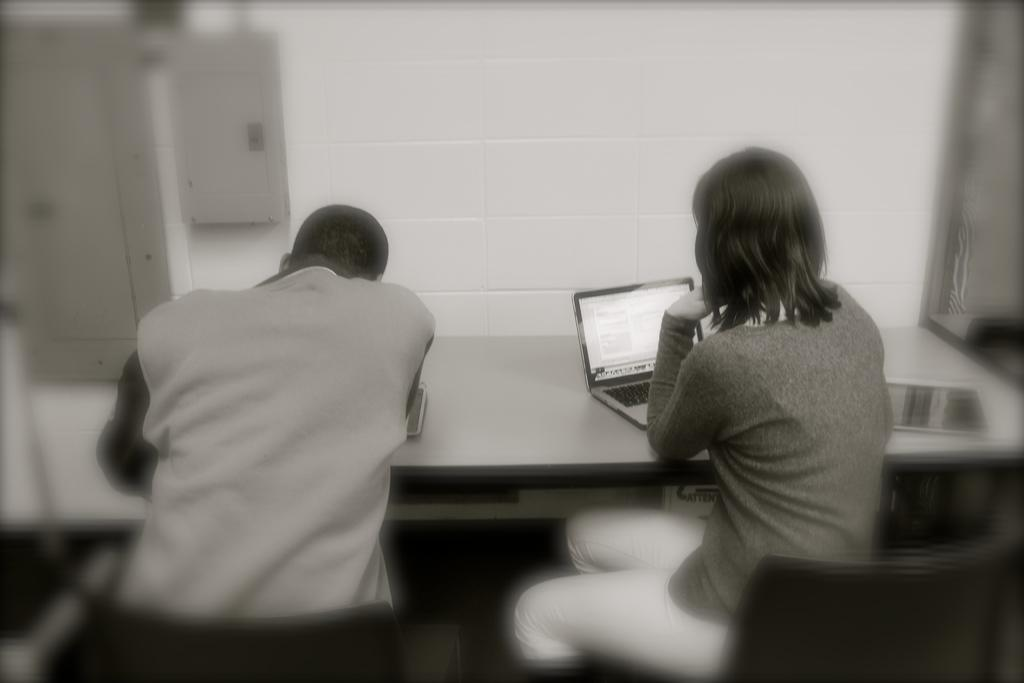What is the lady in the image doing? The lady in the image is using a laptop. On which side of the image is the lady located? The lady is on the right side of the image. What is the person on the left side of the image doing? The person on the left side of the image is bending on a bench. What type of straw is the crow holding in the image? There is no crow or straw present in the image. What is the lady having for dinner in the image? The image does not show the lady having dinner, as she is using a laptop. 